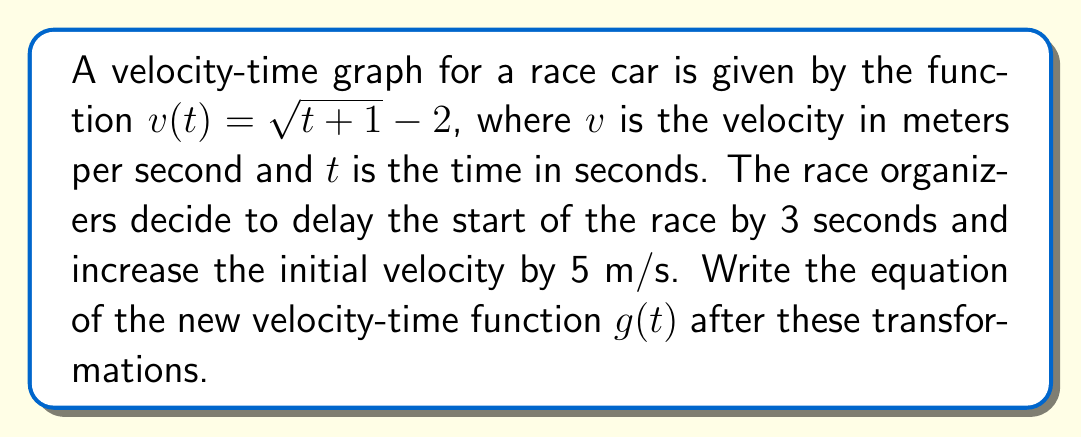Show me your answer to this math problem. To solve this problem, we need to apply horizontal and vertical transformations to the original function $v(t) = \sqrt{t+1} - 2$.

1. Delay the start by 3 seconds:
   This is a horizontal shift to the right by 3 units. We replace $t$ with $(t-3)$:
   $$f(t) = \sqrt{(t-3)+1} - 2 = \sqrt{t-2} - 2$$

2. Increase the initial velocity by 5 m/s:
   This is a vertical shift up by 5 units. We add 5 to the entire function:
   $$g(t) = f(t) + 5 = (\sqrt{t-2} - 2) + 5 = \sqrt{t-2} + 3$$

Therefore, the new velocity-time function $g(t)$ after these transformations is:

$$g(t) = \sqrt{t-2} + 3$$

This function represents the velocity of the race car after delaying the start by 3 seconds and increasing the initial velocity by 5 m/s.
Answer: $$g(t) = \sqrt{t-2} + 3$$ 